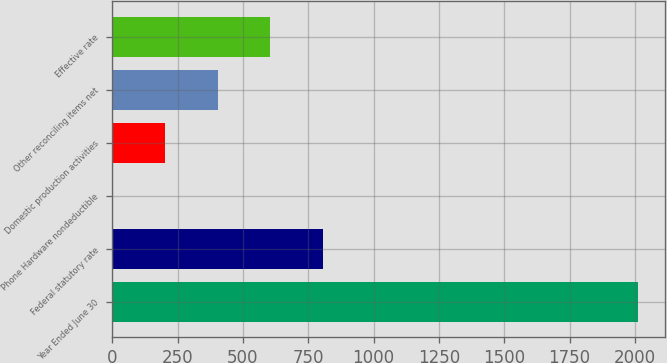Convert chart to OTSL. <chart><loc_0><loc_0><loc_500><loc_500><bar_chart><fcel>Year Ended June 30<fcel>Federal statutory rate<fcel>Phone Hardware nondeductible<fcel>Domestic production activities<fcel>Other reconciling items net<fcel>Effective rate<nl><fcel>2013<fcel>805.77<fcel>0.97<fcel>202.17<fcel>403.37<fcel>604.57<nl></chart> 